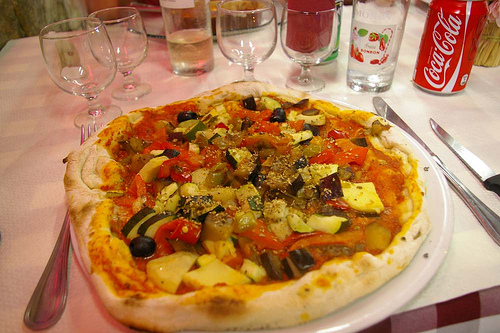On which side of the picture is the tablecloth? The tablecloth, with its rich red color, elegantly unfolds on the right side of the picture, setting a festive mood. 